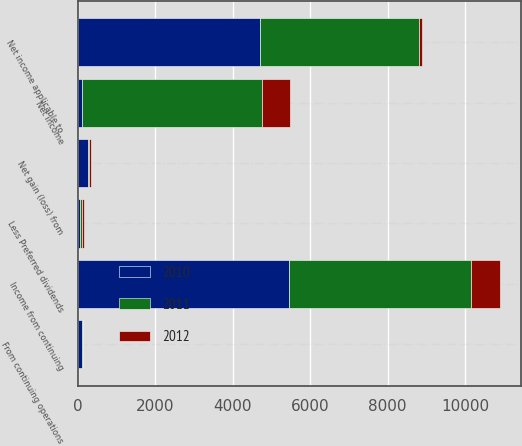Convert chart to OTSL. <chart><loc_0><loc_0><loc_500><loc_500><stacked_bar_chart><ecel><fcel>Income from continuing<fcel>Net gain (loss) from<fcel>Net income<fcel>Net income applicable to<fcel>Less Preferred dividends<fcel>From continuing operations<nl><fcel>2012<fcel>754<fcel>38<fcel>716<fcel>68<fcel>52<fcel>2<nl><fcel>2011<fcel>4689<fcel>44<fcel>4645<fcel>4110<fcel>52<fcel>26<nl><fcel>2010<fcel>5455<fcel>247<fcel>108<fcel>4703<fcel>52<fcel>108<nl></chart> 